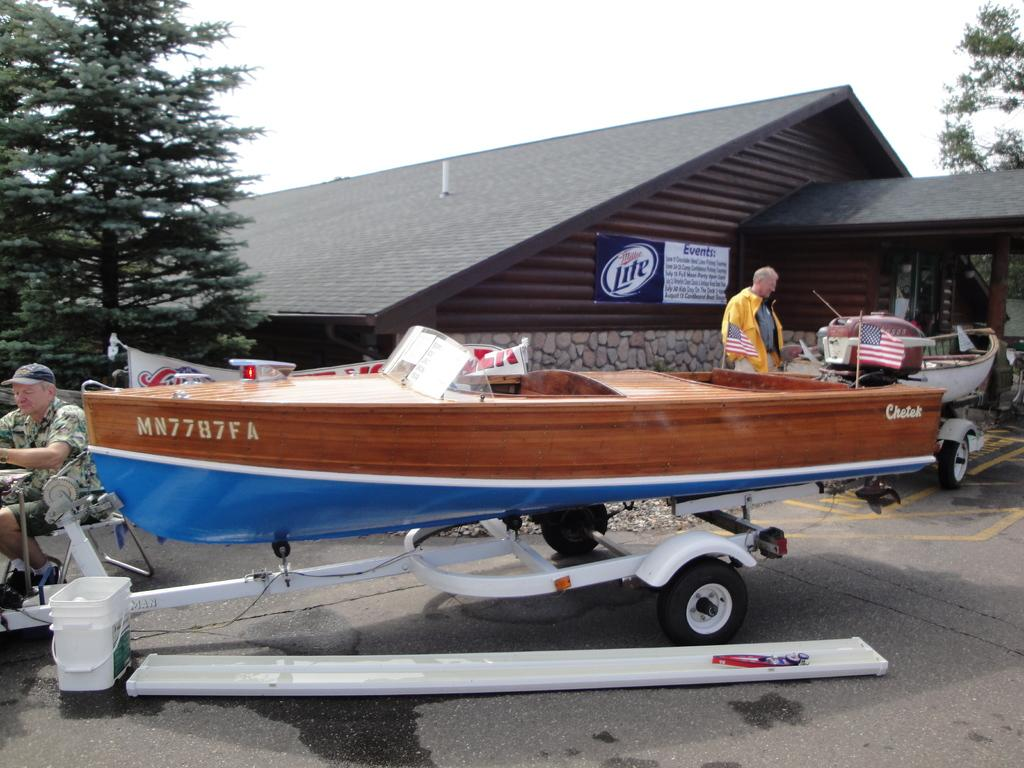<image>
Summarize the visual content of the image. A brown and blue boat with  MN7787FA on it. 